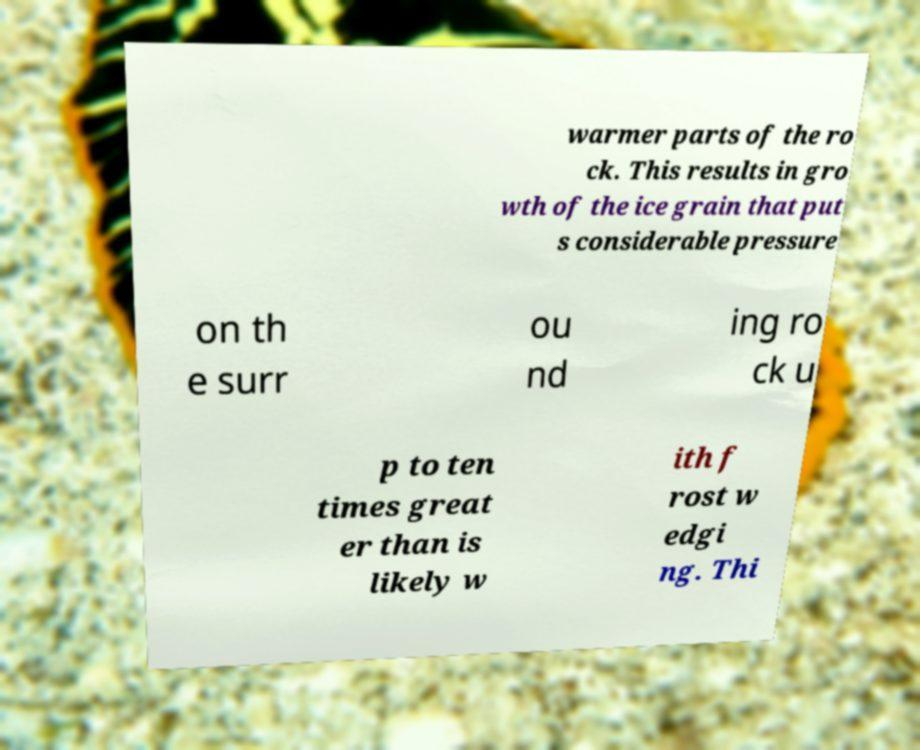Could you extract and type out the text from this image? warmer parts of the ro ck. This results in gro wth of the ice grain that put s considerable pressure on th e surr ou nd ing ro ck u p to ten times great er than is likely w ith f rost w edgi ng. Thi 